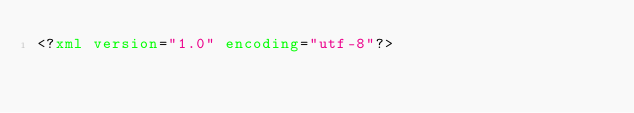Convert code to text. <code><loc_0><loc_0><loc_500><loc_500><_XML_><?xml version="1.0" encoding="utf-8"?></code> 